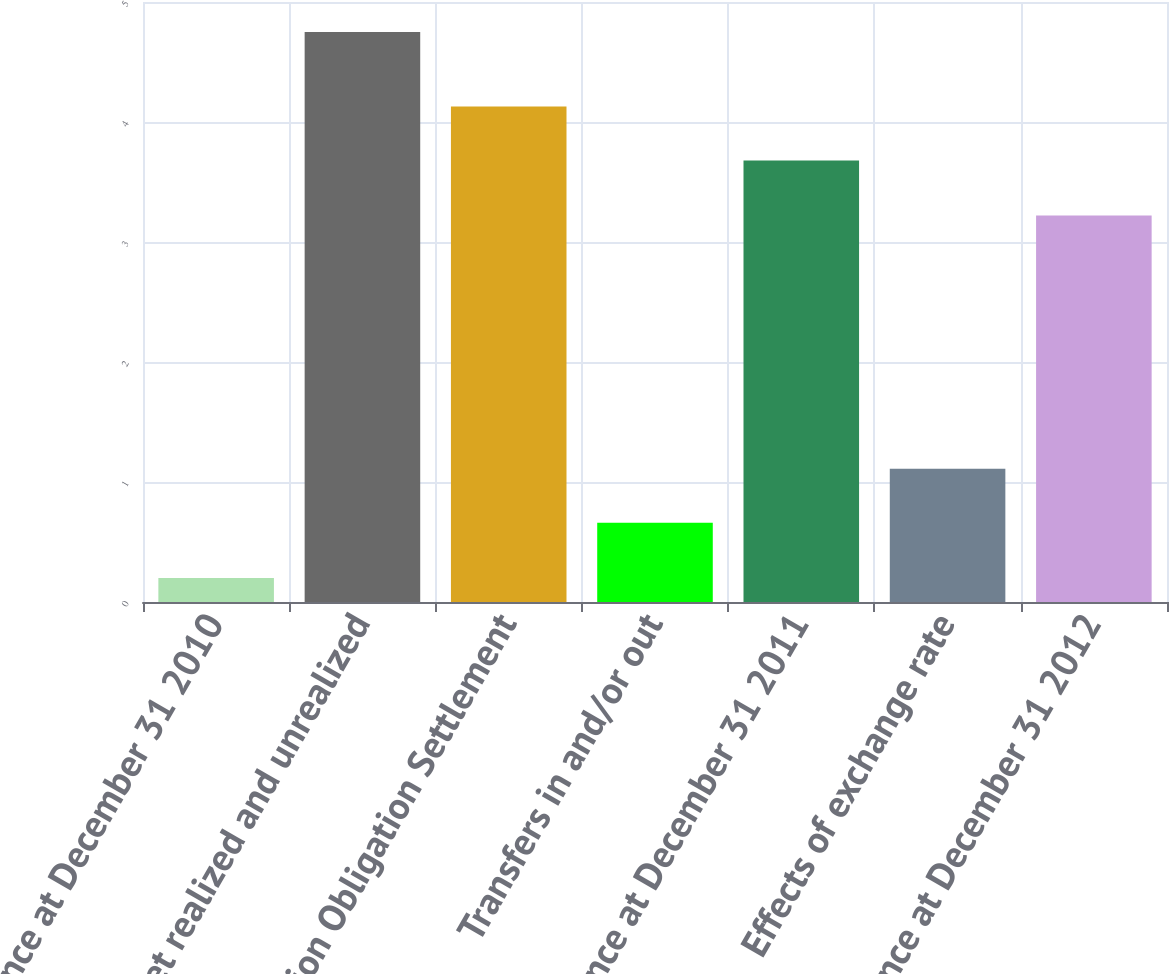Convert chart. <chart><loc_0><loc_0><loc_500><loc_500><bar_chart><fcel>Balance at December 31 2010<fcel>Net realized and unrealized<fcel>Pension Obligation Settlement<fcel>Transfers in and/or out<fcel>Balance at December 31 2011<fcel>Effects of exchange rate<fcel>Balance at December 31 2012<nl><fcel>0.2<fcel>4.75<fcel>4.13<fcel>0.66<fcel>3.68<fcel>1.11<fcel>3.22<nl></chart> 